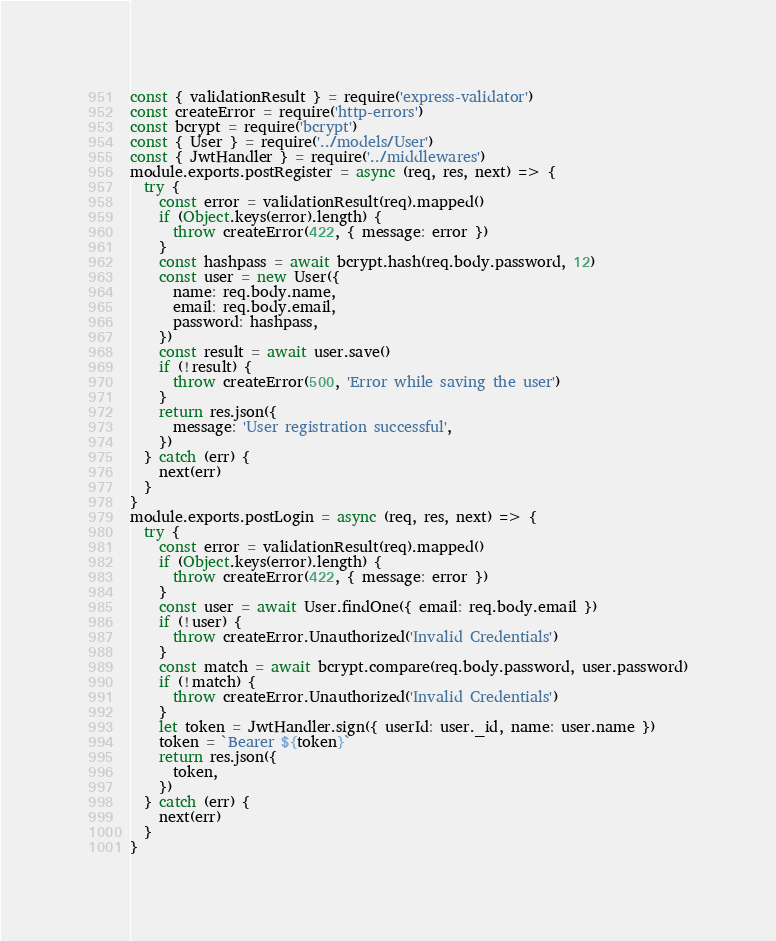Convert code to text. <code><loc_0><loc_0><loc_500><loc_500><_JavaScript_>const { validationResult } = require('express-validator')
const createError = require('http-errors')
const bcrypt = require('bcrypt')
const { User } = require('../models/User')
const { JwtHandler } = require('../middlewares')
module.exports.postRegister = async (req, res, next) => {
  try {
    const error = validationResult(req).mapped()
    if (Object.keys(error).length) {
      throw createError(422, { message: error })
    }
    const hashpass = await bcrypt.hash(req.body.password, 12)
    const user = new User({
      name: req.body.name,
      email: req.body.email,
      password: hashpass,
    })
    const result = await user.save()
    if (!result) {
      throw createError(500, 'Error while saving the user')
    }
    return res.json({
      message: 'User registration successful',
    })
  } catch (err) {
    next(err)
  }
}
module.exports.postLogin = async (req, res, next) => {
  try {
    const error = validationResult(req).mapped()
    if (Object.keys(error).length) {
      throw createError(422, { message: error })
    }
    const user = await User.findOne({ email: req.body.email })
    if (!user) {
      throw createError.Unauthorized('Invalid Credentials')
    }
    const match = await bcrypt.compare(req.body.password, user.password)
    if (!match) {
      throw createError.Unauthorized('Invalid Credentials')
    }
    let token = JwtHandler.sign({ userId: user._id, name: user.name })
    token = `Bearer ${token}`
    return res.json({
      token,
    })
  } catch (err) {
    next(err)
  }
}
</code> 